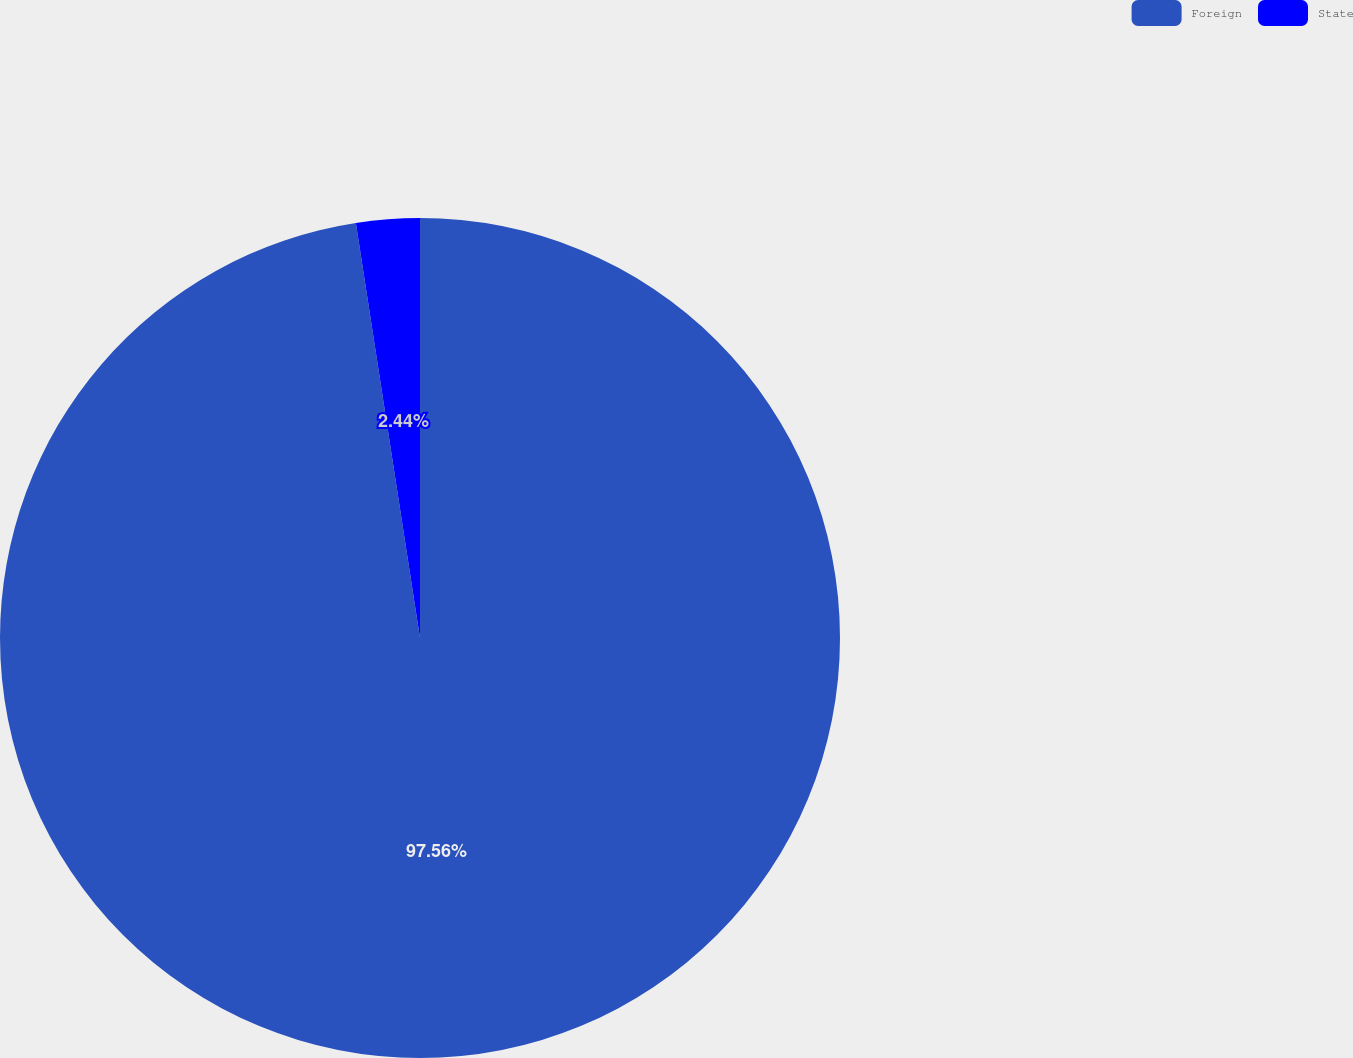Convert chart. <chart><loc_0><loc_0><loc_500><loc_500><pie_chart><fcel>Foreign<fcel>State<nl><fcel>97.56%<fcel>2.44%<nl></chart> 